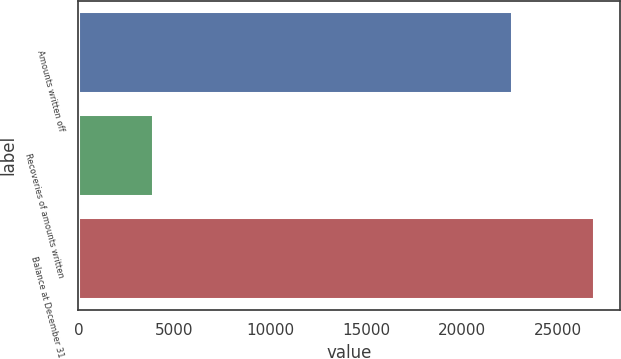Convert chart to OTSL. <chart><loc_0><loc_0><loc_500><loc_500><bar_chart><fcel>Amounts written off<fcel>Recoveries of amounts written<fcel>Balance at December 31<nl><fcel>22607<fcel>3875<fcel>26874<nl></chart> 